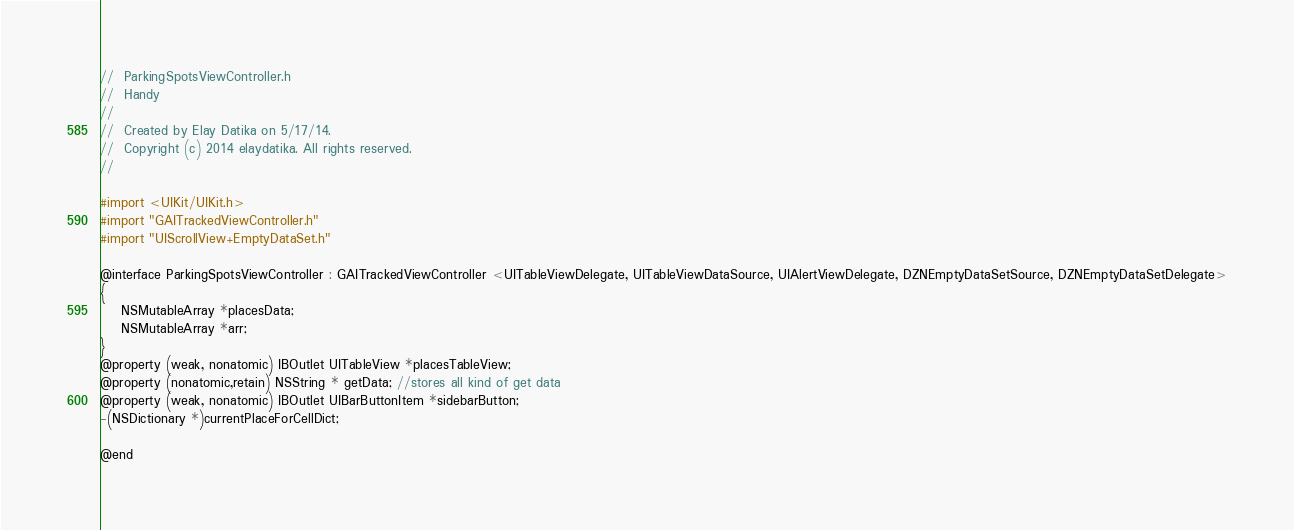<code> <loc_0><loc_0><loc_500><loc_500><_C_>//  ParkingSpotsViewController.h
//  Handy
//
//  Created by Elay Datika on 5/17/14.
//  Copyright (c) 2014 elaydatika. All rights reserved.
//

#import <UIKit/UIKit.h>
#import "GAITrackedViewController.h"
#import "UIScrollView+EmptyDataSet.h"

@interface ParkingSpotsViewController : GAITrackedViewController <UITableViewDelegate, UITableViewDataSource, UIAlertViewDelegate, DZNEmptyDataSetSource, DZNEmptyDataSetDelegate>
{
    NSMutableArray *placesData;
    NSMutableArray *arr;
}
@property (weak, nonatomic) IBOutlet UITableView *placesTableView;
@property (nonatomic,retain) NSString * getData; //stores all kind of get data
@property (weak, nonatomic) IBOutlet UIBarButtonItem *sidebarButton;
-(NSDictionary *)currentPlaceForCellDict;

@end
</code> 